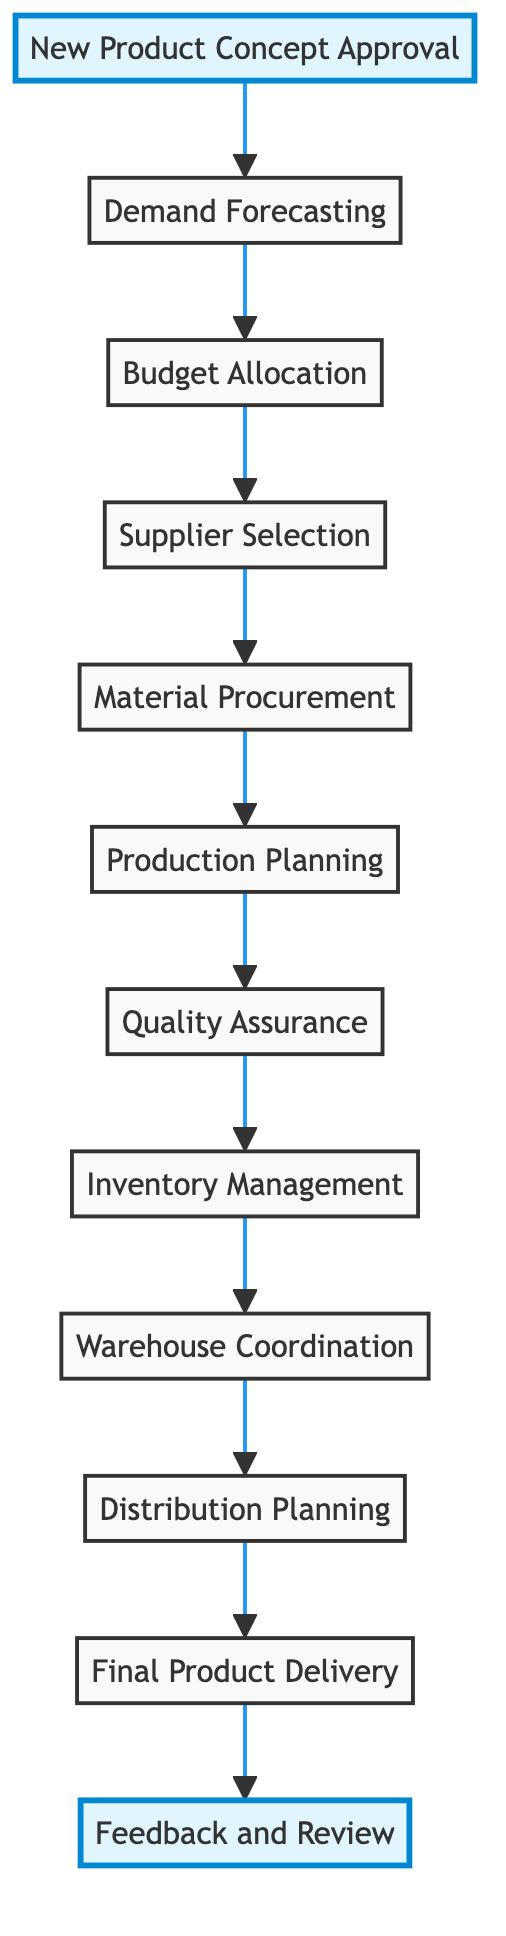What is the first step in the diagram? The first step is the node labeled "New Product Concept Approval," which indicates the initial approval from the Marketing Team for the new product concept.
Answer: New Product Concept Approval How many total steps are there in the process? By counting all the distinct nodes from the start to the end of the flowchart, there are a total of 12 steps in the process.
Answer: 12 What node comes directly after "Material Procurement"? "Production Planning" comes directly after "Material Procurement," indicating that once materials are procured, production is scheduled and planned next.
Answer: Production Planning Which teams are involved in the process from procurement planning to logistics execution? The teams involved are the Marketing Team, Sales Team, Finance, Procurement, Production Team, Quality Control, Logistics Manager, and Logistics Team, highlighting a cross-departmental effort.
Answer: Marketing Team, Sales Team, Finance, Procurement, Production Team, Quality Control, Logistics Manager, Logistics Team What is the last step in the diagram? The last step in the diagram is "Feedback and Review," indicating that after delivery, a review process is conducted to gather feedback for improvements.
Answer: Feedback and Review Which steps are highlighted in the diagram? The highlighted steps are "New Product Concept Approval" and "Feedback and Review," indicating their importance within the overall process.
Answer: New Product Concept Approval, Feedback and Review What is the direct relationship between "Warehouse Coordination" and "Distribution Planning"? "Warehouse Coordination" directly leads to "Distribution Planning," showing that after coordinating with the warehouse, the logistics team plans distribution to various regions.
Answer: Warehouse Coordination → Distribution Planning How does "Quality Assurance" relate to "Inventory Management"? "Quality Assurance" is followed by "Inventory Management," indicating that once quality is assured, inventory is subsequently updated and managed in the ERP system.
Answer: Quality Assurance → Inventory Management 